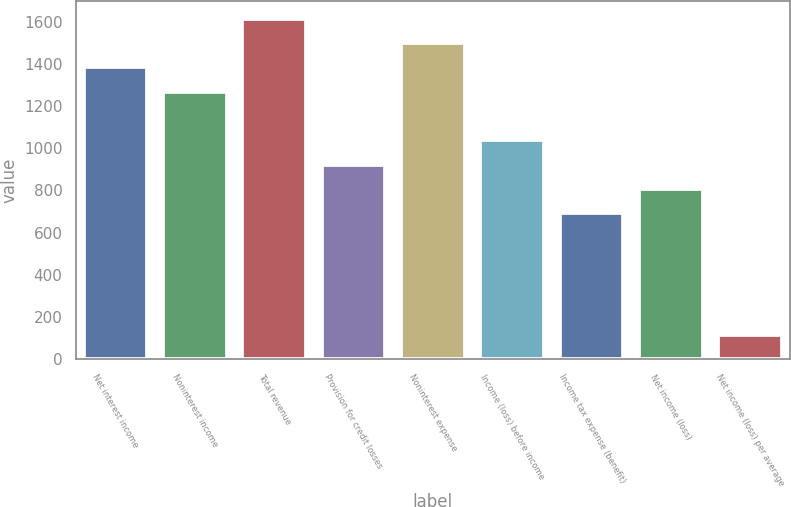Convert chart. <chart><loc_0><loc_0><loc_500><loc_500><bar_chart><fcel>Net interest income<fcel>Noninterest income<fcel>Total revenue<fcel>Provision for credit losses<fcel>Noninterest expense<fcel>Income (loss) before income<fcel>Income tax expense (benefit)<fcel>Net income (loss)<fcel>Net income (loss) per average<nl><fcel>1383.5<fcel>1268.23<fcel>1614.04<fcel>922.42<fcel>1498.77<fcel>1037.69<fcel>691.88<fcel>807.15<fcel>115.53<nl></chart> 